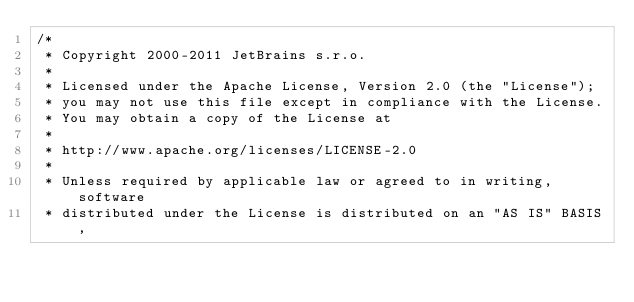Convert code to text. <code><loc_0><loc_0><loc_500><loc_500><_Java_>/*
 * Copyright 2000-2011 JetBrains s.r.o.
 *
 * Licensed under the Apache License, Version 2.0 (the "License");
 * you may not use this file except in compliance with the License.
 * You may obtain a copy of the License at
 *
 * http://www.apache.org/licenses/LICENSE-2.0
 *
 * Unless required by applicable law or agreed to in writing, software
 * distributed under the License is distributed on an "AS IS" BASIS,</code> 